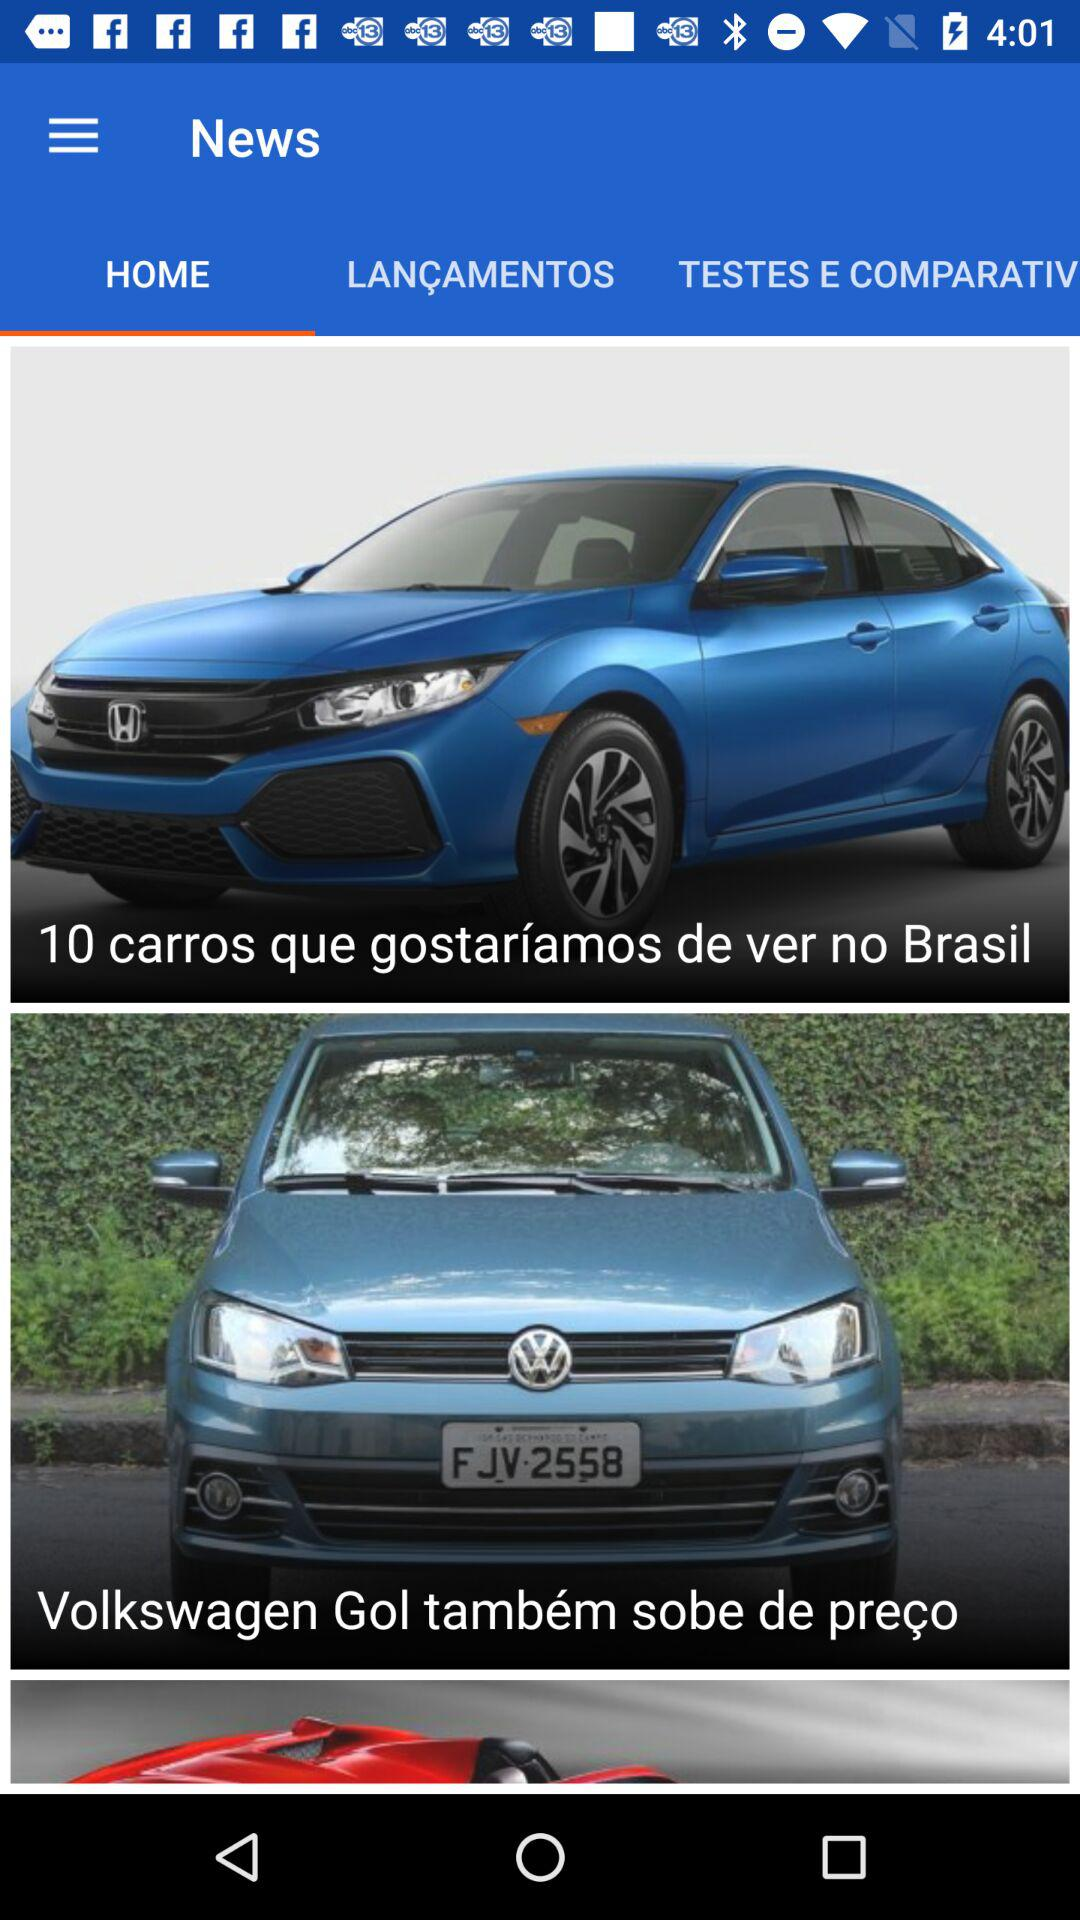Which tab is selected? The selected tab is "HOME". 